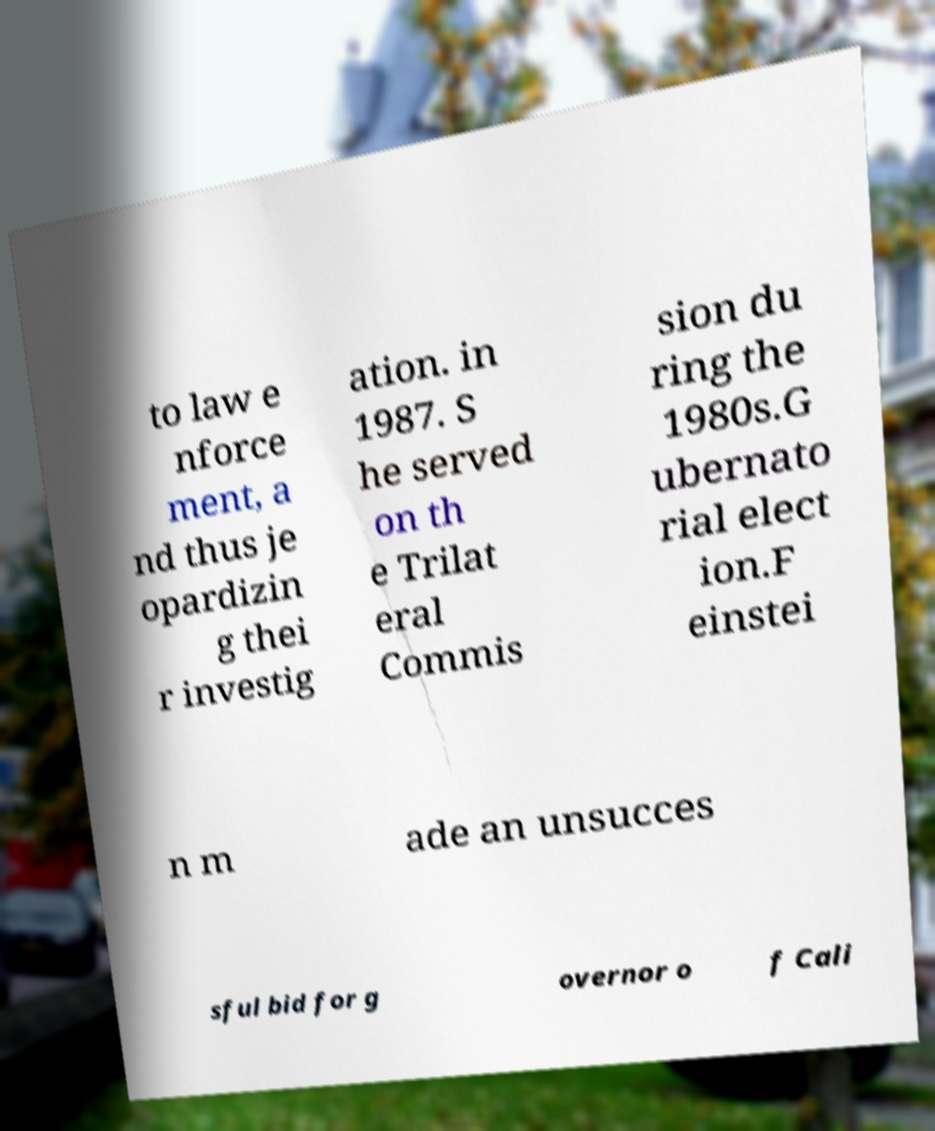What messages or text are displayed in this image? I need them in a readable, typed format. to law e nforce ment, a nd thus je opardizin g thei r investig ation. in 1987. S he served on th e Trilat eral Commis sion du ring the 1980s.G ubernato rial elect ion.F einstei n m ade an unsucces sful bid for g overnor o f Cali 